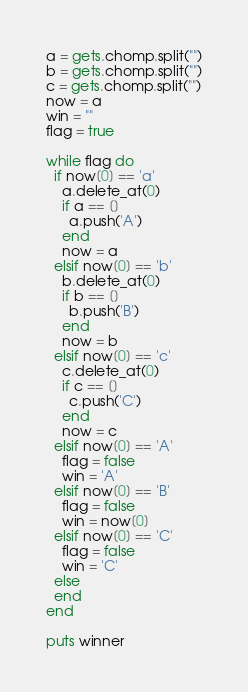Convert code to text. <code><loc_0><loc_0><loc_500><loc_500><_Ruby_>a = gets.chomp.split("")
b = gets.chomp.split("")
c = gets.chomp.split("")
now = a
win = ""
flag = true

while flag do
  if now[0] == 'a' 
    a.delete_at(0)
    if a == []
      a.push('A')
    end
    now = a
  elsif now[0] == 'b'
    b.delete_at(0)
    if b == []
      b.push('B')
    end
    now = b
  elsif now[0] == 'c'
    c.delete_at(0)
    if c == []
      c.push('C')
    end
    now = c
  elsif now[0] == 'A'
    flag = false
    win = 'A'
  elsif now[0] == 'B'
    flag = false
    win = now[0]
  elsif now[0] == 'C'
    flag = false
    win = 'C'
  else
  end
end

puts winner</code> 